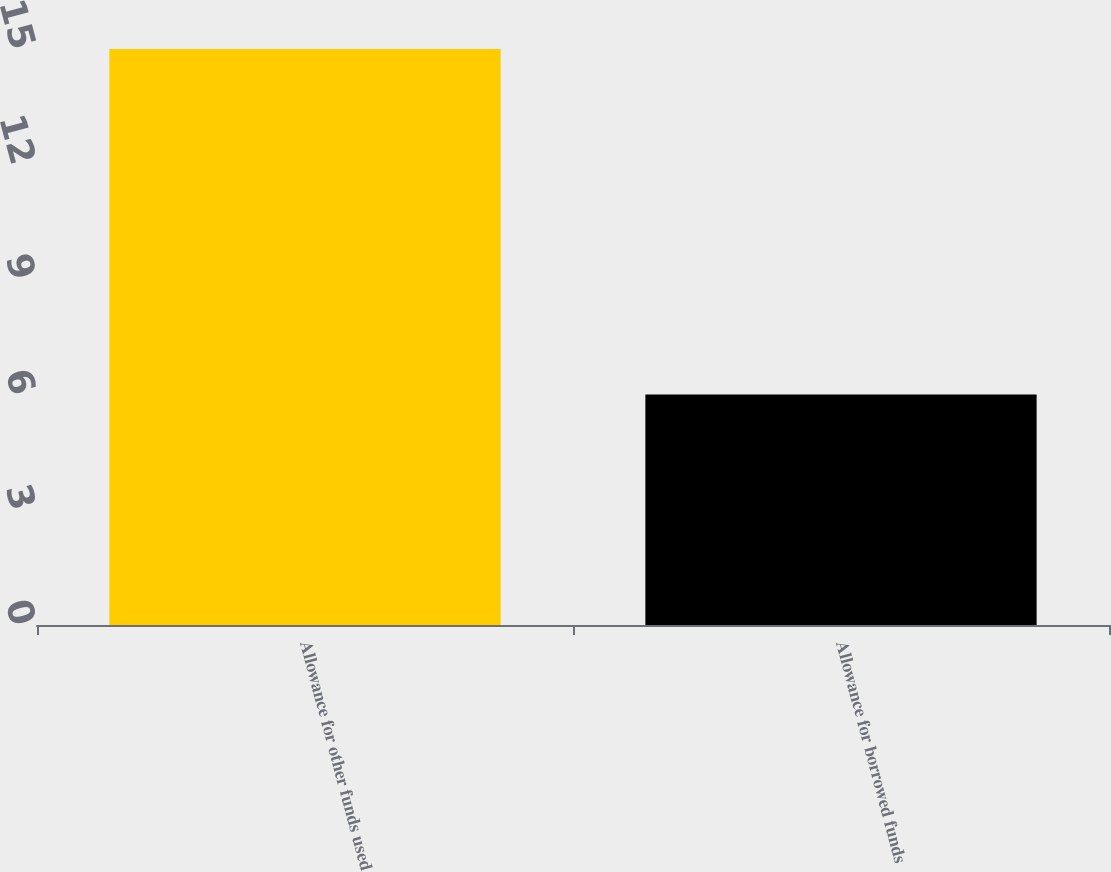<chart> <loc_0><loc_0><loc_500><loc_500><bar_chart><fcel>Allowance for other funds used<fcel>Allowance for borrowed funds<nl><fcel>15<fcel>6<nl></chart> 